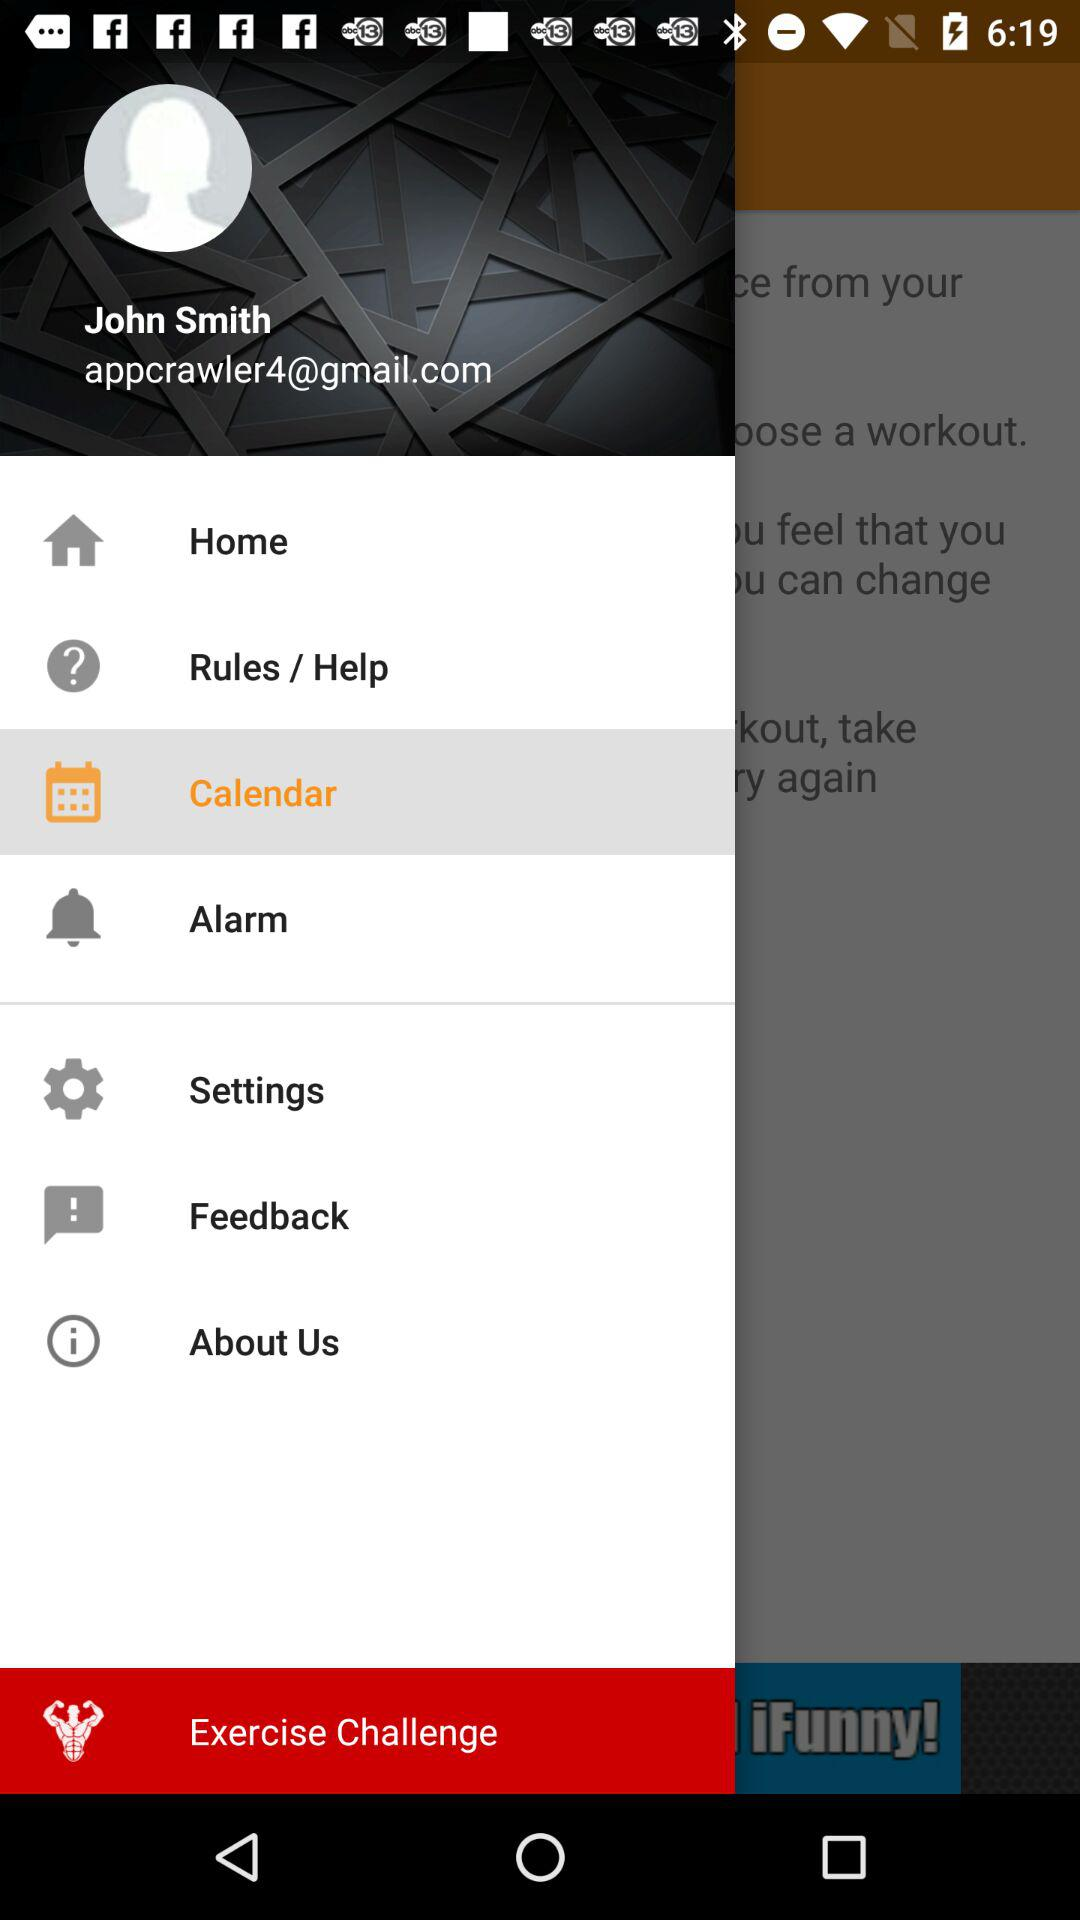What is the name shown on the screen? The name shown on the screen is John Smith. 